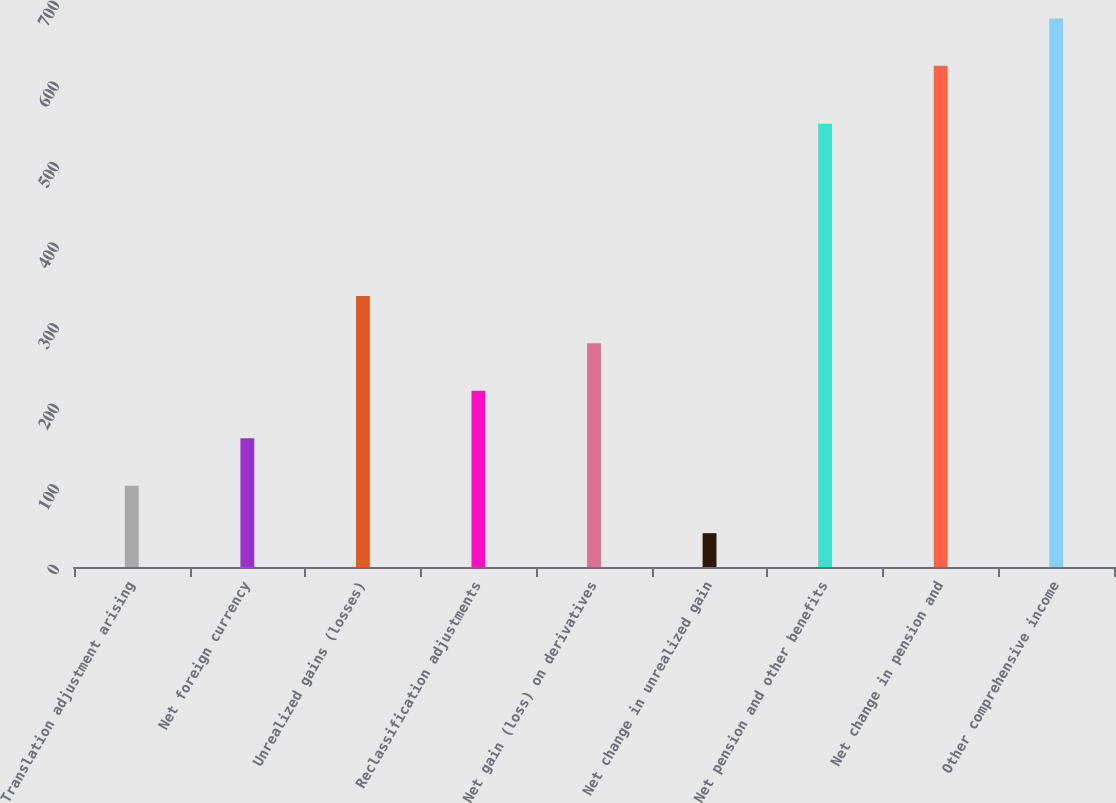Convert chart. <chart><loc_0><loc_0><loc_500><loc_500><bar_chart><fcel>Translation adjustment arising<fcel>Net foreign currency<fcel>Unrealized gains (losses)<fcel>Reclassification adjustments<fcel>Net gain (loss) on derivatives<fcel>Net change in unrealized gain<fcel>Net pension and other benefits<fcel>Net change in pension and<fcel>Other comprehensive income<nl><fcel>100.9<fcel>159.8<fcel>336.5<fcel>218.7<fcel>277.6<fcel>42<fcel>550<fcel>622<fcel>680.9<nl></chart> 